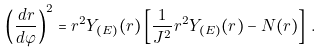Convert formula to latex. <formula><loc_0><loc_0><loc_500><loc_500>\left ( \frac { d r } { d \varphi } \right ) ^ { 2 } = r ^ { 2 } Y _ { ( E ) } ( r ) \left [ \frac { 1 } { J ^ { 2 } } r ^ { 2 } Y _ { ( E ) } ( r ) - N ( r ) \right ] \, .</formula> 